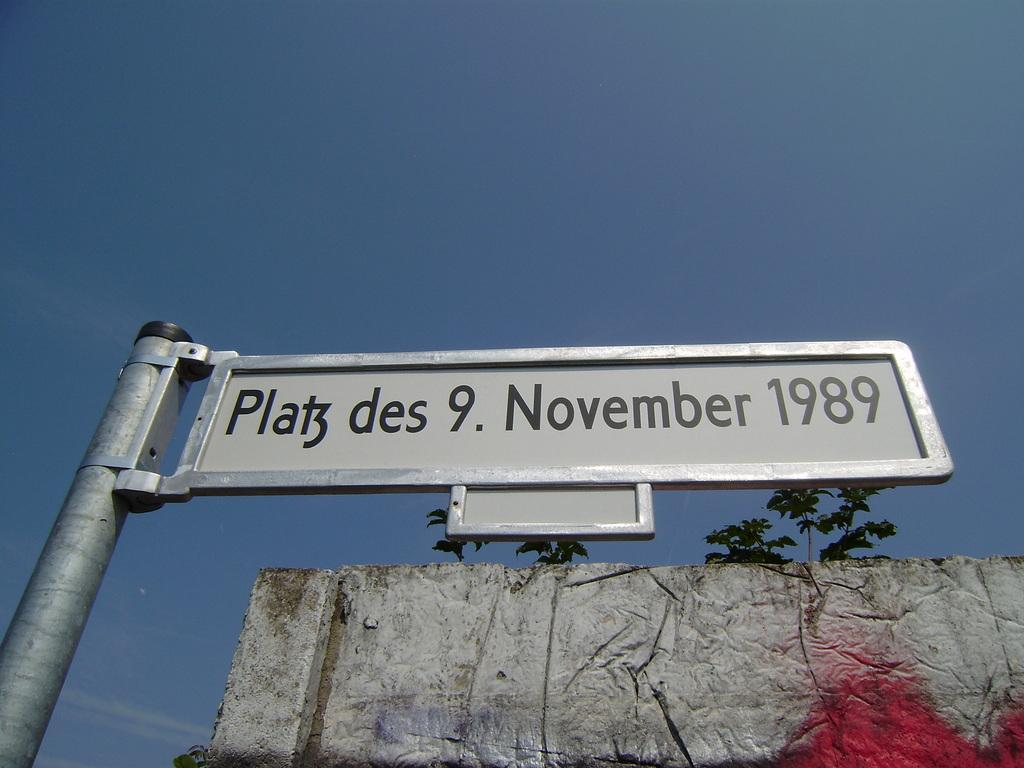What is on the board that is visible in the image? There is text on the board in the image. What else can be seen on the wall behind the board? There is a painting on the wall behind the board. What type of natural scenery is visible in the image? Trees are visible in the image. What is visible at the top of the image? The sky is visible at the top of the image. How many hooks are used to hang the painting in the image? There is no mention of hooks in the image, as the painting is simply on the wall behind the board. What type of soup is being prepared in the image? There is no soup present in the image. 